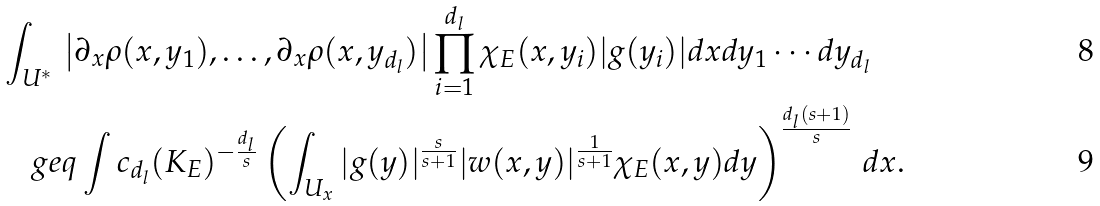<formula> <loc_0><loc_0><loc_500><loc_500>& \int _ { U ^ { * } } \, \left | \partial _ { x } \rho ( x , y _ { 1 } ) , \dots , \partial _ { x } \rho ( x , y _ { d _ { l } } ) \right | \prod _ { i = 1 } ^ { d _ { l } } \chi _ { E } ( x , y _ { i } ) | g ( y _ { i } ) | d x d y _ { 1 } \cdots d y _ { d _ { l } } \\ & \quad g e q \int c _ { d _ { l } } ( K _ { E } ) ^ { - \frac { d _ { l } } { s } } \left ( \int _ { U _ { x } } | g ( y ) | ^ { \frac { s } { s + 1 } } | w ( x , y ) | ^ { \frac { 1 } { s + 1 } } \chi _ { E } ( x , y ) d y \right ) ^ { \frac { d _ { l } ( s + 1 ) } { s } } \, d x .</formula> 